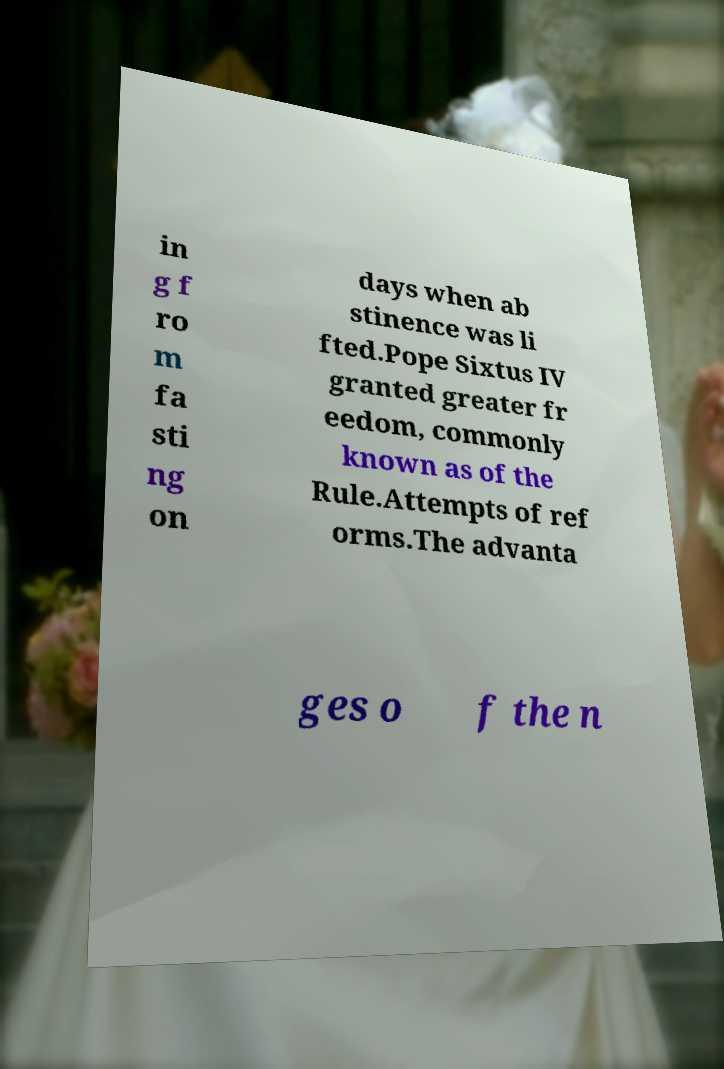What messages or text are displayed in this image? I need them in a readable, typed format. in g f ro m fa sti ng on days when ab stinence was li fted.Pope Sixtus IV granted greater fr eedom, commonly known as of the Rule.Attempts of ref orms.The advanta ges o f the n 